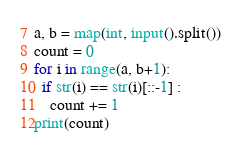Convert code to text. <code><loc_0><loc_0><loc_500><loc_500><_Python_>a, b = map(int, input().split())
count = 0
for i in range(a, b+1):
  if str(i) == str(i)[::-1] :
    count += 1
print(count)</code> 